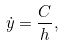Convert formula to latex. <formula><loc_0><loc_0><loc_500><loc_500>\dot { y } = \frac { C } { h } ,</formula> 